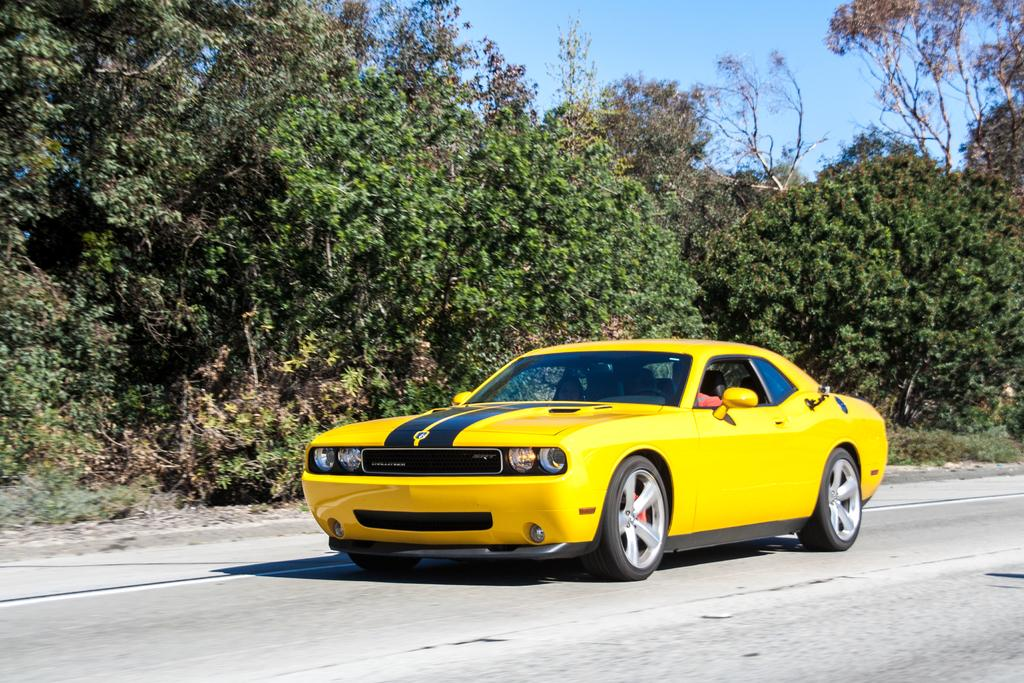What is the main subject of the picture? The main subject of the picture is a car. What is the color of the car? The car is yellow in color. What is the car doing in the picture? The car is moving on a road. What can be seen in the background of the image? There are trees and a clear sky in the background of the image. What type of soap is being used to clean the car in the image? There is no soap or cleaning activity depicted in the image; it simply shows a yellow car moving on a road. Can you tell me how many boats are docked at the harbor in the image? There is no harbor or boats present in the image; it features a yellow car moving on a road. 